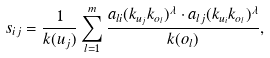<formula> <loc_0><loc_0><loc_500><loc_500>s _ { i j } = \frac { 1 } { k ( u _ { j } ) } \sum ^ { m } _ { l = 1 } \frac { a _ { l i } ( k _ { u _ { j } } k _ { o _ { l } } ) ^ { \lambda } \cdot a _ { l j } ( k _ { u _ { i } } k _ { o _ { l } } ) ^ { \lambda } } { k ( o _ { l } ) } ,</formula> 